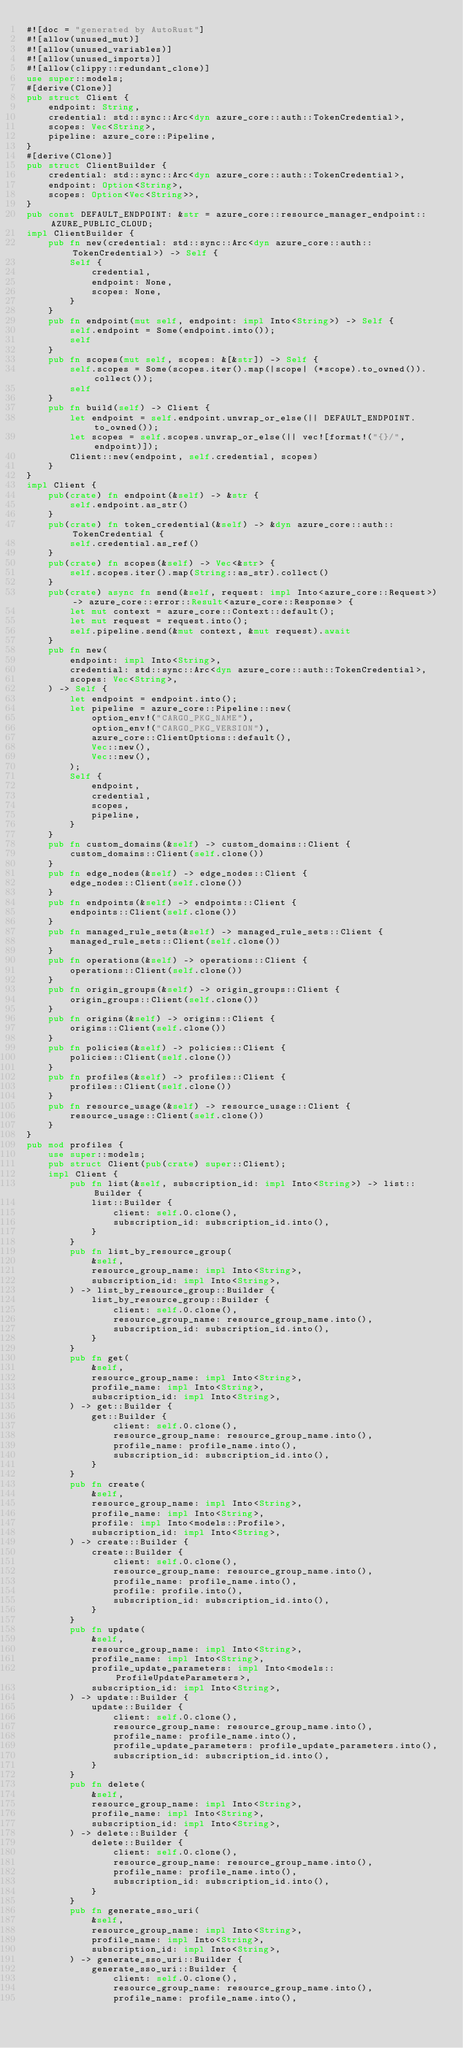Convert code to text. <code><loc_0><loc_0><loc_500><loc_500><_Rust_>#![doc = "generated by AutoRust"]
#![allow(unused_mut)]
#![allow(unused_variables)]
#![allow(unused_imports)]
#![allow(clippy::redundant_clone)]
use super::models;
#[derive(Clone)]
pub struct Client {
    endpoint: String,
    credential: std::sync::Arc<dyn azure_core::auth::TokenCredential>,
    scopes: Vec<String>,
    pipeline: azure_core::Pipeline,
}
#[derive(Clone)]
pub struct ClientBuilder {
    credential: std::sync::Arc<dyn azure_core::auth::TokenCredential>,
    endpoint: Option<String>,
    scopes: Option<Vec<String>>,
}
pub const DEFAULT_ENDPOINT: &str = azure_core::resource_manager_endpoint::AZURE_PUBLIC_CLOUD;
impl ClientBuilder {
    pub fn new(credential: std::sync::Arc<dyn azure_core::auth::TokenCredential>) -> Self {
        Self {
            credential,
            endpoint: None,
            scopes: None,
        }
    }
    pub fn endpoint(mut self, endpoint: impl Into<String>) -> Self {
        self.endpoint = Some(endpoint.into());
        self
    }
    pub fn scopes(mut self, scopes: &[&str]) -> Self {
        self.scopes = Some(scopes.iter().map(|scope| (*scope).to_owned()).collect());
        self
    }
    pub fn build(self) -> Client {
        let endpoint = self.endpoint.unwrap_or_else(|| DEFAULT_ENDPOINT.to_owned());
        let scopes = self.scopes.unwrap_or_else(|| vec![format!("{}/", endpoint)]);
        Client::new(endpoint, self.credential, scopes)
    }
}
impl Client {
    pub(crate) fn endpoint(&self) -> &str {
        self.endpoint.as_str()
    }
    pub(crate) fn token_credential(&self) -> &dyn azure_core::auth::TokenCredential {
        self.credential.as_ref()
    }
    pub(crate) fn scopes(&self) -> Vec<&str> {
        self.scopes.iter().map(String::as_str).collect()
    }
    pub(crate) async fn send(&self, request: impl Into<azure_core::Request>) -> azure_core::error::Result<azure_core::Response> {
        let mut context = azure_core::Context::default();
        let mut request = request.into();
        self.pipeline.send(&mut context, &mut request).await
    }
    pub fn new(
        endpoint: impl Into<String>,
        credential: std::sync::Arc<dyn azure_core::auth::TokenCredential>,
        scopes: Vec<String>,
    ) -> Self {
        let endpoint = endpoint.into();
        let pipeline = azure_core::Pipeline::new(
            option_env!("CARGO_PKG_NAME"),
            option_env!("CARGO_PKG_VERSION"),
            azure_core::ClientOptions::default(),
            Vec::new(),
            Vec::new(),
        );
        Self {
            endpoint,
            credential,
            scopes,
            pipeline,
        }
    }
    pub fn custom_domains(&self) -> custom_domains::Client {
        custom_domains::Client(self.clone())
    }
    pub fn edge_nodes(&self) -> edge_nodes::Client {
        edge_nodes::Client(self.clone())
    }
    pub fn endpoints(&self) -> endpoints::Client {
        endpoints::Client(self.clone())
    }
    pub fn managed_rule_sets(&self) -> managed_rule_sets::Client {
        managed_rule_sets::Client(self.clone())
    }
    pub fn operations(&self) -> operations::Client {
        operations::Client(self.clone())
    }
    pub fn origin_groups(&self) -> origin_groups::Client {
        origin_groups::Client(self.clone())
    }
    pub fn origins(&self) -> origins::Client {
        origins::Client(self.clone())
    }
    pub fn policies(&self) -> policies::Client {
        policies::Client(self.clone())
    }
    pub fn profiles(&self) -> profiles::Client {
        profiles::Client(self.clone())
    }
    pub fn resource_usage(&self) -> resource_usage::Client {
        resource_usage::Client(self.clone())
    }
}
pub mod profiles {
    use super::models;
    pub struct Client(pub(crate) super::Client);
    impl Client {
        pub fn list(&self, subscription_id: impl Into<String>) -> list::Builder {
            list::Builder {
                client: self.0.clone(),
                subscription_id: subscription_id.into(),
            }
        }
        pub fn list_by_resource_group(
            &self,
            resource_group_name: impl Into<String>,
            subscription_id: impl Into<String>,
        ) -> list_by_resource_group::Builder {
            list_by_resource_group::Builder {
                client: self.0.clone(),
                resource_group_name: resource_group_name.into(),
                subscription_id: subscription_id.into(),
            }
        }
        pub fn get(
            &self,
            resource_group_name: impl Into<String>,
            profile_name: impl Into<String>,
            subscription_id: impl Into<String>,
        ) -> get::Builder {
            get::Builder {
                client: self.0.clone(),
                resource_group_name: resource_group_name.into(),
                profile_name: profile_name.into(),
                subscription_id: subscription_id.into(),
            }
        }
        pub fn create(
            &self,
            resource_group_name: impl Into<String>,
            profile_name: impl Into<String>,
            profile: impl Into<models::Profile>,
            subscription_id: impl Into<String>,
        ) -> create::Builder {
            create::Builder {
                client: self.0.clone(),
                resource_group_name: resource_group_name.into(),
                profile_name: profile_name.into(),
                profile: profile.into(),
                subscription_id: subscription_id.into(),
            }
        }
        pub fn update(
            &self,
            resource_group_name: impl Into<String>,
            profile_name: impl Into<String>,
            profile_update_parameters: impl Into<models::ProfileUpdateParameters>,
            subscription_id: impl Into<String>,
        ) -> update::Builder {
            update::Builder {
                client: self.0.clone(),
                resource_group_name: resource_group_name.into(),
                profile_name: profile_name.into(),
                profile_update_parameters: profile_update_parameters.into(),
                subscription_id: subscription_id.into(),
            }
        }
        pub fn delete(
            &self,
            resource_group_name: impl Into<String>,
            profile_name: impl Into<String>,
            subscription_id: impl Into<String>,
        ) -> delete::Builder {
            delete::Builder {
                client: self.0.clone(),
                resource_group_name: resource_group_name.into(),
                profile_name: profile_name.into(),
                subscription_id: subscription_id.into(),
            }
        }
        pub fn generate_sso_uri(
            &self,
            resource_group_name: impl Into<String>,
            profile_name: impl Into<String>,
            subscription_id: impl Into<String>,
        ) -> generate_sso_uri::Builder {
            generate_sso_uri::Builder {
                client: self.0.clone(),
                resource_group_name: resource_group_name.into(),
                profile_name: profile_name.into(),</code> 